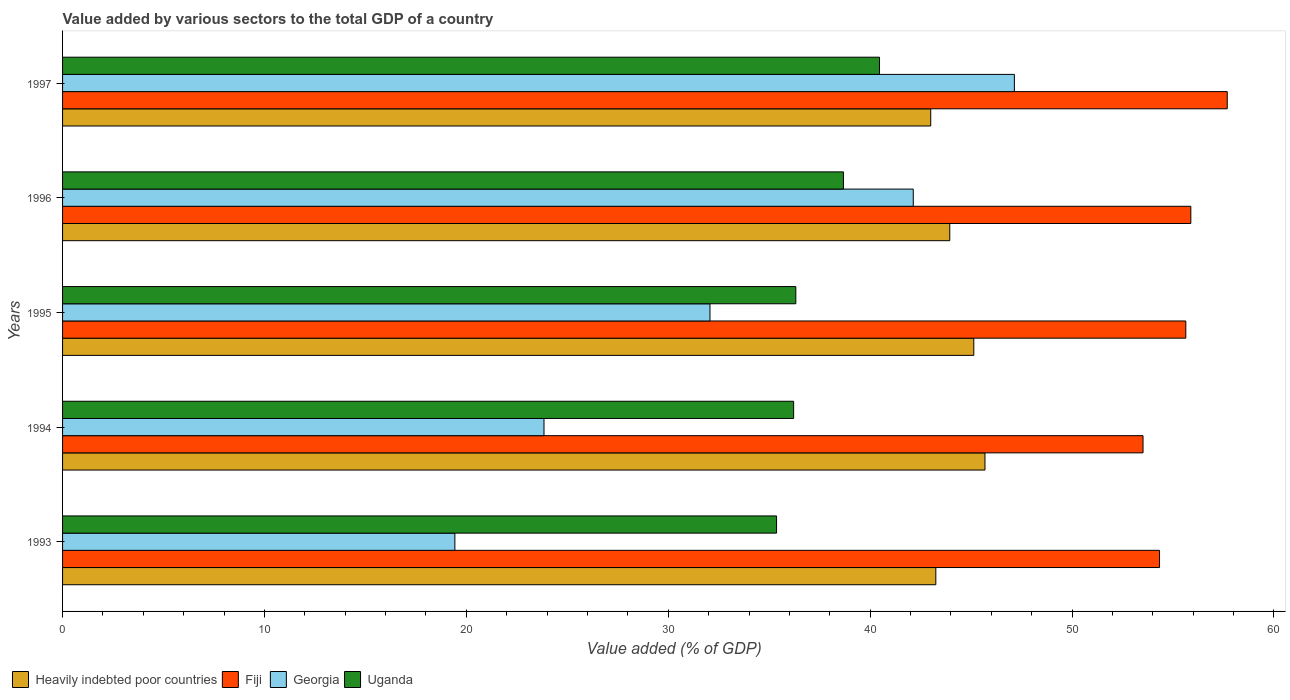How many different coloured bars are there?
Keep it short and to the point. 4. Are the number of bars on each tick of the Y-axis equal?
Give a very brief answer. Yes. What is the label of the 2nd group of bars from the top?
Offer a very short reply. 1996. In how many cases, is the number of bars for a given year not equal to the number of legend labels?
Ensure brevity in your answer.  0. What is the value added by various sectors to the total GDP in Uganda in 1995?
Provide a short and direct response. 36.32. Across all years, what is the maximum value added by various sectors to the total GDP in Uganda?
Ensure brevity in your answer.  40.46. Across all years, what is the minimum value added by various sectors to the total GDP in Fiji?
Keep it short and to the point. 53.52. In which year was the value added by various sectors to the total GDP in Heavily indebted poor countries minimum?
Make the answer very short. 1997. What is the total value added by various sectors to the total GDP in Heavily indebted poor countries in the graph?
Ensure brevity in your answer.  221.02. What is the difference between the value added by various sectors to the total GDP in Georgia in 1994 and that in 1997?
Make the answer very short. -23.3. What is the difference between the value added by various sectors to the total GDP in Heavily indebted poor countries in 1994 and the value added by various sectors to the total GDP in Uganda in 1997?
Offer a terse response. 5.22. What is the average value added by various sectors to the total GDP in Georgia per year?
Provide a succinct answer. 32.92. In the year 1994, what is the difference between the value added by various sectors to the total GDP in Uganda and value added by various sectors to the total GDP in Heavily indebted poor countries?
Your answer should be very brief. -9.48. What is the ratio of the value added by various sectors to the total GDP in Fiji in 1993 to that in 1996?
Your answer should be very brief. 0.97. Is the value added by various sectors to the total GDP in Georgia in 1993 less than that in 1994?
Provide a succinct answer. Yes. What is the difference between the highest and the second highest value added by various sectors to the total GDP in Georgia?
Provide a short and direct response. 5.01. What is the difference between the highest and the lowest value added by various sectors to the total GDP in Fiji?
Provide a short and direct response. 4.17. Is the sum of the value added by various sectors to the total GDP in Georgia in 1993 and 1996 greater than the maximum value added by various sectors to the total GDP in Heavily indebted poor countries across all years?
Your answer should be compact. Yes. What does the 4th bar from the top in 1993 represents?
Your response must be concise. Heavily indebted poor countries. What does the 4th bar from the bottom in 1996 represents?
Offer a very short reply. Uganda. How many bars are there?
Your response must be concise. 20. Are all the bars in the graph horizontal?
Make the answer very short. Yes. What is the difference between two consecutive major ticks on the X-axis?
Provide a succinct answer. 10. Where does the legend appear in the graph?
Ensure brevity in your answer.  Bottom left. What is the title of the graph?
Give a very brief answer. Value added by various sectors to the total GDP of a country. Does "Kenya" appear as one of the legend labels in the graph?
Provide a succinct answer. No. What is the label or title of the X-axis?
Keep it short and to the point. Value added (% of GDP). What is the Value added (% of GDP) in Heavily indebted poor countries in 1993?
Ensure brevity in your answer.  43.25. What is the Value added (% of GDP) of Fiji in 1993?
Your response must be concise. 54.33. What is the Value added (% of GDP) of Georgia in 1993?
Your answer should be very brief. 19.43. What is the Value added (% of GDP) in Uganda in 1993?
Offer a very short reply. 35.36. What is the Value added (% of GDP) in Heavily indebted poor countries in 1994?
Your answer should be compact. 45.69. What is the Value added (% of GDP) in Fiji in 1994?
Provide a succinct answer. 53.52. What is the Value added (% of GDP) in Georgia in 1994?
Your answer should be compact. 23.85. What is the Value added (% of GDP) of Uganda in 1994?
Make the answer very short. 36.21. What is the Value added (% of GDP) in Heavily indebted poor countries in 1995?
Offer a very short reply. 45.13. What is the Value added (% of GDP) in Fiji in 1995?
Offer a very short reply. 55.63. What is the Value added (% of GDP) of Georgia in 1995?
Give a very brief answer. 32.07. What is the Value added (% of GDP) of Uganda in 1995?
Your response must be concise. 36.32. What is the Value added (% of GDP) of Heavily indebted poor countries in 1996?
Ensure brevity in your answer.  43.94. What is the Value added (% of GDP) in Fiji in 1996?
Provide a short and direct response. 55.88. What is the Value added (% of GDP) of Georgia in 1996?
Make the answer very short. 42.14. What is the Value added (% of GDP) in Uganda in 1996?
Your answer should be compact. 38.68. What is the Value added (% of GDP) of Heavily indebted poor countries in 1997?
Your answer should be very brief. 43. What is the Value added (% of GDP) in Fiji in 1997?
Ensure brevity in your answer.  57.69. What is the Value added (% of GDP) of Georgia in 1997?
Make the answer very short. 47.14. What is the Value added (% of GDP) of Uganda in 1997?
Provide a succinct answer. 40.46. Across all years, what is the maximum Value added (% of GDP) of Heavily indebted poor countries?
Your response must be concise. 45.69. Across all years, what is the maximum Value added (% of GDP) in Fiji?
Your response must be concise. 57.69. Across all years, what is the maximum Value added (% of GDP) in Georgia?
Make the answer very short. 47.14. Across all years, what is the maximum Value added (% of GDP) in Uganda?
Keep it short and to the point. 40.46. Across all years, what is the minimum Value added (% of GDP) in Heavily indebted poor countries?
Ensure brevity in your answer.  43. Across all years, what is the minimum Value added (% of GDP) of Fiji?
Keep it short and to the point. 53.52. Across all years, what is the minimum Value added (% of GDP) of Georgia?
Provide a short and direct response. 19.43. Across all years, what is the minimum Value added (% of GDP) in Uganda?
Give a very brief answer. 35.36. What is the total Value added (% of GDP) of Heavily indebted poor countries in the graph?
Provide a short and direct response. 221.02. What is the total Value added (% of GDP) of Fiji in the graph?
Offer a very short reply. 277.06. What is the total Value added (% of GDP) in Georgia in the graph?
Your response must be concise. 164.62. What is the total Value added (% of GDP) of Uganda in the graph?
Give a very brief answer. 187.03. What is the difference between the Value added (% of GDP) of Heavily indebted poor countries in 1993 and that in 1994?
Offer a very short reply. -2.43. What is the difference between the Value added (% of GDP) in Fiji in 1993 and that in 1994?
Your answer should be compact. 0.82. What is the difference between the Value added (% of GDP) of Georgia in 1993 and that in 1994?
Your answer should be very brief. -4.41. What is the difference between the Value added (% of GDP) in Uganda in 1993 and that in 1994?
Offer a terse response. -0.85. What is the difference between the Value added (% of GDP) of Heavily indebted poor countries in 1993 and that in 1995?
Provide a succinct answer. -1.88. What is the difference between the Value added (% of GDP) of Fiji in 1993 and that in 1995?
Make the answer very short. -1.3. What is the difference between the Value added (% of GDP) of Georgia in 1993 and that in 1995?
Ensure brevity in your answer.  -12.64. What is the difference between the Value added (% of GDP) of Uganda in 1993 and that in 1995?
Provide a succinct answer. -0.95. What is the difference between the Value added (% of GDP) in Heavily indebted poor countries in 1993 and that in 1996?
Ensure brevity in your answer.  -0.69. What is the difference between the Value added (% of GDP) of Fiji in 1993 and that in 1996?
Your response must be concise. -1.55. What is the difference between the Value added (% of GDP) in Georgia in 1993 and that in 1996?
Your response must be concise. -22.7. What is the difference between the Value added (% of GDP) in Uganda in 1993 and that in 1996?
Make the answer very short. -3.31. What is the difference between the Value added (% of GDP) in Heavily indebted poor countries in 1993 and that in 1997?
Keep it short and to the point. 0.25. What is the difference between the Value added (% of GDP) of Fiji in 1993 and that in 1997?
Provide a short and direct response. -3.35. What is the difference between the Value added (% of GDP) of Georgia in 1993 and that in 1997?
Keep it short and to the point. -27.71. What is the difference between the Value added (% of GDP) in Uganda in 1993 and that in 1997?
Your answer should be compact. -5.1. What is the difference between the Value added (% of GDP) of Heavily indebted poor countries in 1994 and that in 1995?
Ensure brevity in your answer.  0.55. What is the difference between the Value added (% of GDP) in Fiji in 1994 and that in 1995?
Your answer should be compact. -2.12. What is the difference between the Value added (% of GDP) of Georgia in 1994 and that in 1995?
Provide a short and direct response. -8.22. What is the difference between the Value added (% of GDP) in Uganda in 1994 and that in 1995?
Your answer should be very brief. -0.11. What is the difference between the Value added (% of GDP) in Heavily indebted poor countries in 1994 and that in 1996?
Your answer should be very brief. 1.74. What is the difference between the Value added (% of GDP) in Fiji in 1994 and that in 1996?
Your answer should be very brief. -2.37. What is the difference between the Value added (% of GDP) of Georgia in 1994 and that in 1996?
Provide a succinct answer. -18.29. What is the difference between the Value added (% of GDP) in Uganda in 1994 and that in 1996?
Your answer should be very brief. -2.47. What is the difference between the Value added (% of GDP) of Heavily indebted poor countries in 1994 and that in 1997?
Your response must be concise. 2.69. What is the difference between the Value added (% of GDP) in Fiji in 1994 and that in 1997?
Offer a terse response. -4.17. What is the difference between the Value added (% of GDP) of Georgia in 1994 and that in 1997?
Ensure brevity in your answer.  -23.3. What is the difference between the Value added (% of GDP) of Uganda in 1994 and that in 1997?
Offer a terse response. -4.25. What is the difference between the Value added (% of GDP) in Heavily indebted poor countries in 1995 and that in 1996?
Your answer should be very brief. 1.19. What is the difference between the Value added (% of GDP) in Fiji in 1995 and that in 1996?
Offer a very short reply. -0.25. What is the difference between the Value added (% of GDP) in Georgia in 1995 and that in 1996?
Keep it short and to the point. -10.07. What is the difference between the Value added (% of GDP) of Uganda in 1995 and that in 1996?
Provide a succinct answer. -2.36. What is the difference between the Value added (% of GDP) of Heavily indebted poor countries in 1995 and that in 1997?
Offer a terse response. 2.13. What is the difference between the Value added (% of GDP) of Fiji in 1995 and that in 1997?
Your answer should be compact. -2.05. What is the difference between the Value added (% of GDP) in Georgia in 1995 and that in 1997?
Your answer should be very brief. -15.08. What is the difference between the Value added (% of GDP) of Uganda in 1995 and that in 1997?
Your answer should be compact. -4.15. What is the difference between the Value added (% of GDP) in Heavily indebted poor countries in 1996 and that in 1997?
Give a very brief answer. 0.94. What is the difference between the Value added (% of GDP) of Fiji in 1996 and that in 1997?
Ensure brevity in your answer.  -1.8. What is the difference between the Value added (% of GDP) in Georgia in 1996 and that in 1997?
Your answer should be very brief. -5.01. What is the difference between the Value added (% of GDP) of Uganda in 1996 and that in 1997?
Your answer should be very brief. -1.79. What is the difference between the Value added (% of GDP) in Heavily indebted poor countries in 1993 and the Value added (% of GDP) in Fiji in 1994?
Give a very brief answer. -10.26. What is the difference between the Value added (% of GDP) of Heavily indebted poor countries in 1993 and the Value added (% of GDP) of Georgia in 1994?
Offer a very short reply. 19.41. What is the difference between the Value added (% of GDP) of Heavily indebted poor countries in 1993 and the Value added (% of GDP) of Uganda in 1994?
Your response must be concise. 7.04. What is the difference between the Value added (% of GDP) in Fiji in 1993 and the Value added (% of GDP) in Georgia in 1994?
Provide a short and direct response. 30.49. What is the difference between the Value added (% of GDP) in Fiji in 1993 and the Value added (% of GDP) in Uganda in 1994?
Make the answer very short. 18.12. What is the difference between the Value added (% of GDP) of Georgia in 1993 and the Value added (% of GDP) of Uganda in 1994?
Keep it short and to the point. -16.78. What is the difference between the Value added (% of GDP) of Heavily indebted poor countries in 1993 and the Value added (% of GDP) of Fiji in 1995?
Make the answer very short. -12.38. What is the difference between the Value added (% of GDP) in Heavily indebted poor countries in 1993 and the Value added (% of GDP) in Georgia in 1995?
Your answer should be very brief. 11.19. What is the difference between the Value added (% of GDP) in Heavily indebted poor countries in 1993 and the Value added (% of GDP) in Uganda in 1995?
Provide a succinct answer. 6.93. What is the difference between the Value added (% of GDP) of Fiji in 1993 and the Value added (% of GDP) of Georgia in 1995?
Provide a succinct answer. 22.27. What is the difference between the Value added (% of GDP) in Fiji in 1993 and the Value added (% of GDP) in Uganda in 1995?
Ensure brevity in your answer.  18.02. What is the difference between the Value added (% of GDP) in Georgia in 1993 and the Value added (% of GDP) in Uganda in 1995?
Give a very brief answer. -16.89. What is the difference between the Value added (% of GDP) in Heavily indebted poor countries in 1993 and the Value added (% of GDP) in Fiji in 1996?
Your answer should be very brief. -12.63. What is the difference between the Value added (% of GDP) of Heavily indebted poor countries in 1993 and the Value added (% of GDP) of Georgia in 1996?
Offer a terse response. 1.12. What is the difference between the Value added (% of GDP) in Heavily indebted poor countries in 1993 and the Value added (% of GDP) in Uganda in 1996?
Offer a terse response. 4.58. What is the difference between the Value added (% of GDP) in Fiji in 1993 and the Value added (% of GDP) in Georgia in 1996?
Ensure brevity in your answer.  12.2. What is the difference between the Value added (% of GDP) of Fiji in 1993 and the Value added (% of GDP) of Uganda in 1996?
Keep it short and to the point. 15.66. What is the difference between the Value added (% of GDP) of Georgia in 1993 and the Value added (% of GDP) of Uganda in 1996?
Offer a very short reply. -19.25. What is the difference between the Value added (% of GDP) of Heavily indebted poor countries in 1993 and the Value added (% of GDP) of Fiji in 1997?
Your answer should be very brief. -14.43. What is the difference between the Value added (% of GDP) of Heavily indebted poor countries in 1993 and the Value added (% of GDP) of Georgia in 1997?
Offer a terse response. -3.89. What is the difference between the Value added (% of GDP) in Heavily indebted poor countries in 1993 and the Value added (% of GDP) in Uganda in 1997?
Ensure brevity in your answer.  2.79. What is the difference between the Value added (% of GDP) of Fiji in 1993 and the Value added (% of GDP) of Georgia in 1997?
Give a very brief answer. 7.19. What is the difference between the Value added (% of GDP) of Fiji in 1993 and the Value added (% of GDP) of Uganda in 1997?
Provide a succinct answer. 13.87. What is the difference between the Value added (% of GDP) in Georgia in 1993 and the Value added (% of GDP) in Uganda in 1997?
Offer a terse response. -21.03. What is the difference between the Value added (% of GDP) in Heavily indebted poor countries in 1994 and the Value added (% of GDP) in Fiji in 1995?
Give a very brief answer. -9.95. What is the difference between the Value added (% of GDP) of Heavily indebted poor countries in 1994 and the Value added (% of GDP) of Georgia in 1995?
Make the answer very short. 13.62. What is the difference between the Value added (% of GDP) in Heavily indebted poor countries in 1994 and the Value added (% of GDP) in Uganda in 1995?
Offer a terse response. 9.37. What is the difference between the Value added (% of GDP) in Fiji in 1994 and the Value added (% of GDP) in Georgia in 1995?
Give a very brief answer. 21.45. What is the difference between the Value added (% of GDP) of Fiji in 1994 and the Value added (% of GDP) of Uganda in 1995?
Keep it short and to the point. 17.2. What is the difference between the Value added (% of GDP) in Georgia in 1994 and the Value added (% of GDP) in Uganda in 1995?
Provide a succinct answer. -12.47. What is the difference between the Value added (% of GDP) of Heavily indebted poor countries in 1994 and the Value added (% of GDP) of Fiji in 1996?
Keep it short and to the point. -10.2. What is the difference between the Value added (% of GDP) in Heavily indebted poor countries in 1994 and the Value added (% of GDP) in Georgia in 1996?
Give a very brief answer. 3.55. What is the difference between the Value added (% of GDP) in Heavily indebted poor countries in 1994 and the Value added (% of GDP) in Uganda in 1996?
Keep it short and to the point. 7.01. What is the difference between the Value added (% of GDP) of Fiji in 1994 and the Value added (% of GDP) of Georgia in 1996?
Your answer should be very brief. 11.38. What is the difference between the Value added (% of GDP) of Fiji in 1994 and the Value added (% of GDP) of Uganda in 1996?
Provide a short and direct response. 14.84. What is the difference between the Value added (% of GDP) in Georgia in 1994 and the Value added (% of GDP) in Uganda in 1996?
Provide a short and direct response. -14.83. What is the difference between the Value added (% of GDP) in Heavily indebted poor countries in 1994 and the Value added (% of GDP) in Fiji in 1997?
Give a very brief answer. -12. What is the difference between the Value added (% of GDP) of Heavily indebted poor countries in 1994 and the Value added (% of GDP) of Georgia in 1997?
Offer a very short reply. -1.46. What is the difference between the Value added (% of GDP) in Heavily indebted poor countries in 1994 and the Value added (% of GDP) in Uganda in 1997?
Make the answer very short. 5.22. What is the difference between the Value added (% of GDP) of Fiji in 1994 and the Value added (% of GDP) of Georgia in 1997?
Offer a very short reply. 6.37. What is the difference between the Value added (% of GDP) in Fiji in 1994 and the Value added (% of GDP) in Uganda in 1997?
Your response must be concise. 13.05. What is the difference between the Value added (% of GDP) of Georgia in 1994 and the Value added (% of GDP) of Uganda in 1997?
Your response must be concise. -16.62. What is the difference between the Value added (% of GDP) of Heavily indebted poor countries in 1995 and the Value added (% of GDP) of Fiji in 1996?
Offer a very short reply. -10.75. What is the difference between the Value added (% of GDP) in Heavily indebted poor countries in 1995 and the Value added (% of GDP) in Georgia in 1996?
Make the answer very short. 3. What is the difference between the Value added (% of GDP) in Heavily indebted poor countries in 1995 and the Value added (% of GDP) in Uganda in 1996?
Your response must be concise. 6.46. What is the difference between the Value added (% of GDP) of Fiji in 1995 and the Value added (% of GDP) of Georgia in 1996?
Offer a terse response. 13.5. What is the difference between the Value added (% of GDP) of Fiji in 1995 and the Value added (% of GDP) of Uganda in 1996?
Your answer should be compact. 16.96. What is the difference between the Value added (% of GDP) of Georgia in 1995 and the Value added (% of GDP) of Uganda in 1996?
Give a very brief answer. -6.61. What is the difference between the Value added (% of GDP) of Heavily indebted poor countries in 1995 and the Value added (% of GDP) of Fiji in 1997?
Offer a terse response. -12.55. What is the difference between the Value added (% of GDP) in Heavily indebted poor countries in 1995 and the Value added (% of GDP) in Georgia in 1997?
Make the answer very short. -2.01. What is the difference between the Value added (% of GDP) of Heavily indebted poor countries in 1995 and the Value added (% of GDP) of Uganda in 1997?
Your answer should be very brief. 4.67. What is the difference between the Value added (% of GDP) of Fiji in 1995 and the Value added (% of GDP) of Georgia in 1997?
Give a very brief answer. 8.49. What is the difference between the Value added (% of GDP) of Fiji in 1995 and the Value added (% of GDP) of Uganda in 1997?
Offer a very short reply. 15.17. What is the difference between the Value added (% of GDP) of Georgia in 1995 and the Value added (% of GDP) of Uganda in 1997?
Your response must be concise. -8.4. What is the difference between the Value added (% of GDP) in Heavily indebted poor countries in 1996 and the Value added (% of GDP) in Fiji in 1997?
Give a very brief answer. -13.74. What is the difference between the Value added (% of GDP) in Heavily indebted poor countries in 1996 and the Value added (% of GDP) in Georgia in 1997?
Your answer should be very brief. -3.2. What is the difference between the Value added (% of GDP) of Heavily indebted poor countries in 1996 and the Value added (% of GDP) of Uganda in 1997?
Give a very brief answer. 3.48. What is the difference between the Value added (% of GDP) of Fiji in 1996 and the Value added (% of GDP) of Georgia in 1997?
Offer a very short reply. 8.74. What is the difference between the Value added (% of GDP) in Fiji in 1996 and the Value added (% of GDP) in Uganda in 1997?
Give a very brief answer. 15.42. What is the difference between the Value added (% of GDP) of Georgia in 1996 and the Value added (% of GDP) of Uganda in 1997?
Ensure brevity in your answer.  1.67. What is the average Value added (% of GDP) of Heavily indebted poor countries per year?
Offer a very short reply. 44.2. What is the average Value added (% of GDP) in Fiji per year?
Provide a succinct answer. 55.41. What is the average Value added (% of GDP) in Georgia per year?
Your answer should be very brief. 32.92. What is the average Value added (% of GDP) of Uganda per year?
Offer a terse response. 37.41. In the year 1993, what is the difference between the Value added (% of GDP) in Heavily indebted poor countries and Value added (% of GDP) in Fiji?
Provide a short and direct response. -11.08. In the year 1993, what is the difference between the Value added (% of GDP) of Heavily indebted poor countries and Value added (% of GDP) of Georgia?
Give a very brief answer. 23.82. In the year 1993, what is the difference between the Value added (% of GDP) in Heavily indebted poor countries and Value added (% of GDP) in Uganda?
Offer a very short reply. 7.89. In the year 1993, what is the difference between the Value added (% of GDP) of Fiji and Value added (% of GDP) of Georgia?
Your answer should be compact. 34.9. In the year 1993, what is the difference between the Value added (% of GDP) of Fiji and Value added (% of GDP) of Uganda?
Provide a succinct answer. 18.97. In the year 1993, what is the difference between the Value added (% of GDP) in Georgia and Value added (% of GDP) in Uganda?
Ensure brevity in your answer.  -15.93. In the year 1994, what is the difference between the Value added (% of GDP) in Heavily indebted poor countries and Value added (% of GDP) in Fiji?
Your response must be concise. -7.83. In the year 1994, what is the difference between the Value added (% of GDP) of Heavily indebted poor countries and Value added (% of GDP) of Georgia?
Your response must be concise. 21.84. In the year 1994, what is the difference between the Value added (% of GDP) in Heavily indebted poor countries and Value added (% of GDP) in Uganda?
Provide a short and direct response. 9.48. In the year 1994, what is the difference between the Value added (% of GDP) of Fiji and Value added (% of GDP) of Georgia?
Give a very brief answer. 29.67. In the year 1994, what is the difference between the Value added (% of GDP) in Fiji and Value added (% of GDP) in Uganda?
Your response must be concise. 17.31. In the year 1994, what is the difference between the Value added (% of GDP) of Georgia and Value added (% of GDP) of Uganda?
Your response must be concise. -12.37. In the year 1995, what is the difference between the Value added (% of GDP) in Heavily indebted poor countries and Value added (% of GDP) in Fiji?
Your answer should be compact. -10.5. In the year 1995, what is the difference between the Value added (% of GDP) in Heavily indebted poor countries and Value added (% of GDP) in Georgia?
Ensure brevity in your answer.  13.07. In the year 1995, what is the difference between the Value added (% of GDP) of Heavily indebted poor countries and Value added (% of GDP) of Uganda?
Give a very brief answer. 8.82. In the year 1995, what is the difference between the Value added (% of GDP) of Fiji and Value added (% of GDP) of Georgia?
Offer a very short reply. 23.57. In the year 1995, what is the difference between the Value added (% of GDP) of Fiji and Value added (% of GDP) of Uganda?
Keep it short and to the point. 19.32. In the year 1995, what is the difference between the Value added (% of GDP) of Georgia and Value added (% of GDP) of Uganda?
Offer a very short reply. -4.25. In the year 1996, what is the difference between the Value added (% of GDP) of Heavily indebted poor countries and Value added (% of GDP) of Fiji?
Provide a succinct answer. -11.94. In the year 1996, what is the difference between the Value added (% of GDP) of Heavily indebted poor countries and Value added (% of GDP) of Georgia?
Offer a terse response. 1.81. In the year 1996, what is the difference between the Value added (% of GDP) in Heavily indebted poor countries and Value added (% of GDP) in Uganda?
Your response must be concise. 5.27. In the year 1996, what is the difference between the Value added (% of GDP) of Fiji and Value added (% of GDP) of Georgia?
Provide a succinct answer. 13.75. In the year 1996, what is the difference between the Value added (% of GDP) in Fiji and Value added (% of GDP) in Uganda?
Ensure brevity in your answer.  17.21. In the year 1996, what is the difference between the Value added (% of GDP) of Georgia and Value added (% of GDP) of Uganda?
Ensure brevity in your answer.  3.46. In the year 1997, what is the difference between the Value added (% of GDP) in Heavily indebted poor countries and Value added (% of GDP) in Fiji?
Your answer should be very brief. -14.69. In the year 1997, what is the difference between the Value added (% of GDP) of Heavily indebted poor countries and Value added (% of GDP) of Georgia?
Provide a succinct answer. -4.14. In the year 1997, what is the difference between the Value added (% of GDP) in Heavily indebted poor countries and Value added (% of GDP) in Uganda?
Offer a very short reply. 2.54. In the year 1997, what is the difference between the Value added (% of GDP) of Fiji and Value added (% of GDP) of Georgia?
Keep it short and to the point. 10.54. In the year 1997, what is the difference between the Value added (% of GDP) in Fiji and Value added (% of GDP) in Uganda?
Your response must be concise. 17.22. In the year 1997, what is the difference between the Value added (% of GDP) in Georgia and Value added (% of GDP) in Uganda?
Ensure brevity in your answer.  6.68. What is the ratio of the Value added (% of GDP) of Heavily indebted poor countries in 1993 to that in 1994?
Offer a very short reply. 0.95. What is the ratio of the Value added (% of GDP) of Fiji in 1993 to that in 1994?
Ensure brevity in your answer.  1.02. What is the ratio of the Value added (% of GDP) in Georgia in 1993 to that in 1994?
Your answer should be very brief. 0.81. What is the ratio of the Value added (% of GDP) of Uganda in 1993 to that in 1994?
Make the answer very short. 0.98. What is the ratio of the Value added (% of GDP) of Heavily indebted poor countries in 1993 to that in 1995?
Provide a succinct answer. 0.96. What is the ratio of the Value added (% of GDP) of Fiji in 1993 to that in 1995?
Ensure brevity in your answer.  0.98. What is the ratio of the Value added (% of GDP) in Georgia in 1993 to that in 1995?
Your response must be concise. 0.61. What is the ratio of the Value added (% of GDP) in Uganda in 1993 to that in 1995?
Provide a short and direct response. 0.97. What is the ratio of the Value added (% of GDP) of Heavily indebted poor countries in 1993 to that in 1996?
Make the answer very short. 0.98. What is the ratio of the Value added (% of GDP) in Fiji in 1993 to that in 1996?
Keep it short and to the point. 0.97. What is the ratio of the Value added (% of GDP) in Georgia in 1993 to that in 1996?
Your response must be concise. 0.46. What is the ratio of the Value added (% of GDP) of Uganda in 1993 to that in 1996?
Your answer should be very brief. 0.91. What is the ratio of the Value added (% of GDP) in Heavily indebted poor countries in 1993 to that in 1997?
Provide a short and direct response. 1.01. What is the ratio of the Value added (% of GDP) in Fiji in 1993 to that in 1997?
Provide a succinct answer. 0.94. What is the ratio of the Value added (% of GDP) of Georgia in 1993 to that in 1997?
Ensure brevity in your answer.  0.41. What is the ratio of the Value added (% of GDP) in Uganda in 1993 to that in 1997?
Offer a very short reply. 0.87. What is the ratio of the Value added (% of GDP) in Heavily indebted poor countries in 1994 to that in 1995?
Make the answer very short. 1.01. What is the ratio of the Value added (% of GDP) of Fiji in 1994 to that in 1995?
Provide a succinct answer. 0.96. What is the ratio of the Value added (% of GDP) in Georgia in 1994 to that in 1995?
Offer a very short reply. 0.74. What is the ratio of the Value added (% of GDP) of Uganda in 1994 to that in 1995?
Give a very brief answer. 1. What is the ratio of the Value added (% of GDP) in Heavily indebted poor countries in 1994 to that in 1996?
Offer a very short reply. 1.04. What is the ratio of the Value added (% of GDP) of Fiji in 1994 to that in 1996?
Offer a terse response. 0.96. What is the ratio of the Value added (% of GDP) in Georgia in 1994 to that in 1996?
Offer a very short reply. 0.57. What is the ratio of the Value added (% of GDP) in Uganda in 1994 to that in 1996?
Keep it short and to the point. 0.94. What is the ratio of the Value added (% of GDP) in Heavily indebted poor countries in 1994 to that in 1997?
Provide a succinct answer. 1.06. What is the ratio of the Value added (% of GDP) in Fiji in 1994 to that in 1997?
Offer a terse response. 0.93. What is the ratio of the Value added (% of GDP) in Georgia in 1994 to that in 1997?
Offer a terse response. 0.51. What is the ratio of the Value added (% of GDP) in Uganda in 1994 to that in 1997?
Your answer should be compact. 0.89. What is the ratio of the Value added (% of GDP) of Heavily indebted poor countries in 1995 to that in 1996?
Offer a very short reply. 1.03. What is the ratio of the Value added (% of GDP) of Fiji in 1995 to that in 1996?
Make the answer very short. 1. What is the ratio of the Value added (% of GDP) in Georgia in 1995 to that in 1996?
Offer a terse response. 0.76. What is the ratio of the Value added (% of GDP) of Uganda in 1995 to that in 1996?
Your answer should be very brief. 0.94. What is the ratio of the Value added (% of GDP) in Heavily indebted poor countries in 1995 to that in 1997?
Your answer should be compact. 1.05. What is the ratio of the Value added (% of GDP) in Fiji in 1995 to that in 1997?
Your response must be concise. 0.96. What is the ratio of the Value added (% of GDP) of Georgia in 1995 to that in 1997?
Your response must be concise. 0.68. What is the ratio of the Value added (% of GDP) of Uganda in 1995 to that in 1997?
Keep it short and to the point. 0.9. What is the ratio of the Value added (% of GDP) of Heavily indebted poor countries in 1996 to that in 1997?
Your answer should be very brief. 1.02. What is the ratio of the Value added (% of GDP) of Fiji in 1996 to that in 1997?
Your answer should be compact. 0.97. What is the ratio of the Value added (% of GDP) of Georgia in 1996 to that in 1997?
Your response must be concise. 0.89. What is the ratio of the Value added (% of GDP) of Uganda in 1996 to that in 1997?
Offer a very short reply. 0.96. What is the difference between the highest and the second highest Value added (% of GDP) of Heavily indebted poor countries?
Provide a short and direct response. 0.55. What is the difference between the highest and the second highest Value added (% of GDP) of Fiji?
Your answer should be very brief. 1.8. What is the difference between the highest and the second highest Value added (% of GDP) of Georgia?
Make the answer very short. 5.01. What is the difference between the highest and the second highest Value added (% of GDP) in Uganda?
Offer a terse response. 1.79. What is the difference between the highest and the lowest Value added (% of GDP) of Heavily indebted poor countries?
Your answer should be compact. 2.69. What is the difference between the highest and the lowest Value added (% of GDP) in Fiji?
Give a very brief answer. 4.17. What is the difference between the highest and the lowest Value added (% of GDP) in Georgia?
Your response must be concise. 27.71. What is the difference between the highest and the lowest Value added (% of GDP) of Uganda?
Your response must be concise. 5.1. 